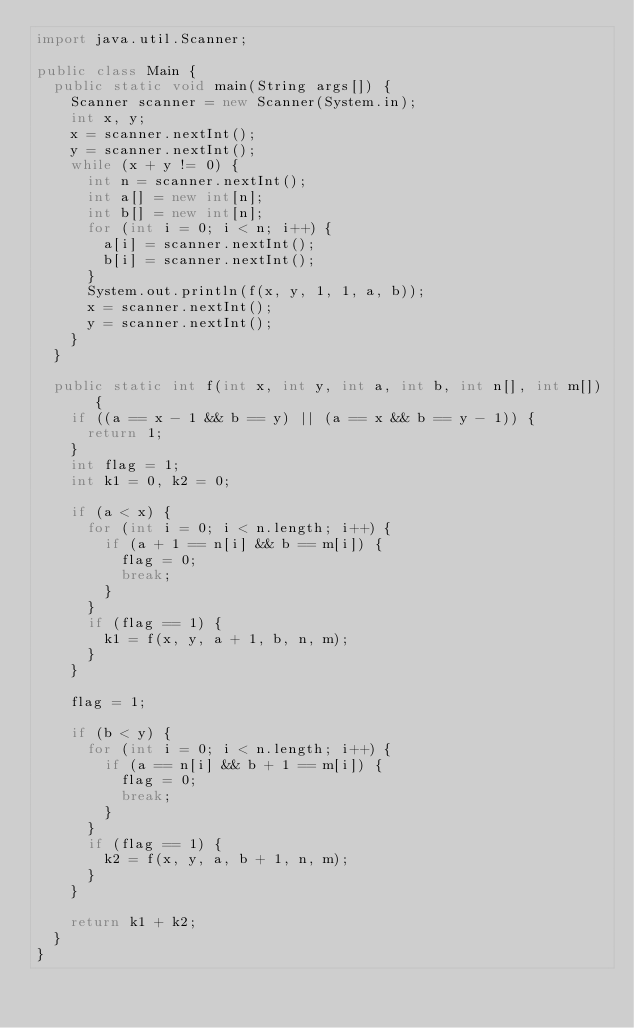Convert code to text. <code><loc_0><loc_0><loc_500><loc_500><_Java_>import java.util.Scanner;

public class Main {
	public static void main(String args[]) {
		Scanner scanner = new Scanner(System.in);
		int x, y;
		x = scanner.nextInt();
		y = scanner.nextInt();
		while (x + y != 0) {
			int n = scanner.nextInt();
			int a[] = new int[n];
			int b[] = new int[n];
			for (int i = 0; i < n; i++) {
				a[i] = scanner.nextInt();
				b[i] = scanner.nextInt();
			}
			System.out.println(f(x, y, 1, 1, a, b));
			x = scanner.nextInt();
			y = scanner.nextInt();
		}
	}

	public static int f(int x, int y, int a, int b, int n[], int m[]) {
		if ((a == x - 1 && b == y) || (a == x && b == y - 1)) {
			return 1;
		}
		int flag = 1;
		int k1 = 0, k2 = 0;

		if (a < x) {
			for (int i = 0; i < n.length; i++) {
				if (a + 1 == n[i] && b == m[i]) {
					flag = 0;
					break;
				}
			}
			if (flag == 1) {
				k1 = f(x, y, a + 1, b, n, m);
			}
		}

		flag = 1;

		if (b < y) {
			for (int i = 0; i < n.length; i++) {
				if (a == n[i] && b + 1 == m[i]) {
					flag = 0;
					break;
				}
			}
			if (flag == 1) {
				k2 = f(x, y, a, b + 1, n, m);
			}
		}

		return k1 + k2;
	}
}</code> 